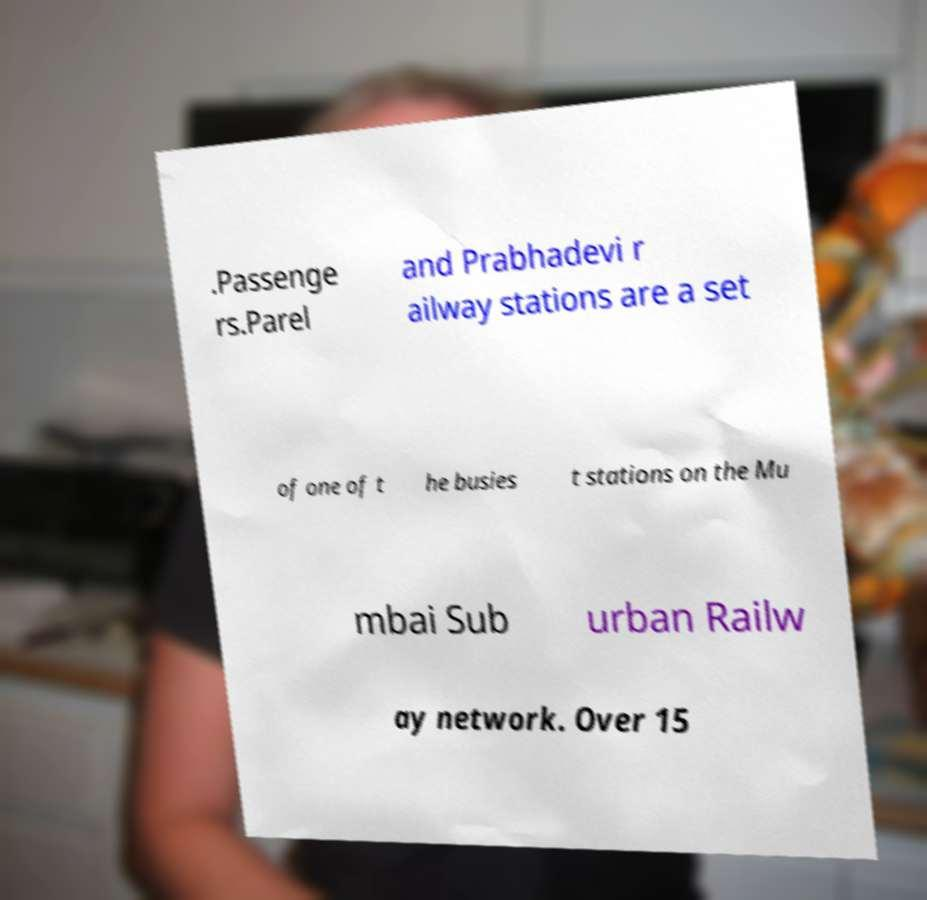There's text embedded in this image that I need extracted. Can you transcribe it verbatim? .Passenge rs.Parel and Prabhadevi r ailway stations are a set of one of t he busies t stations on the Mu mbai Sub urban Railw ay network. Over 15 